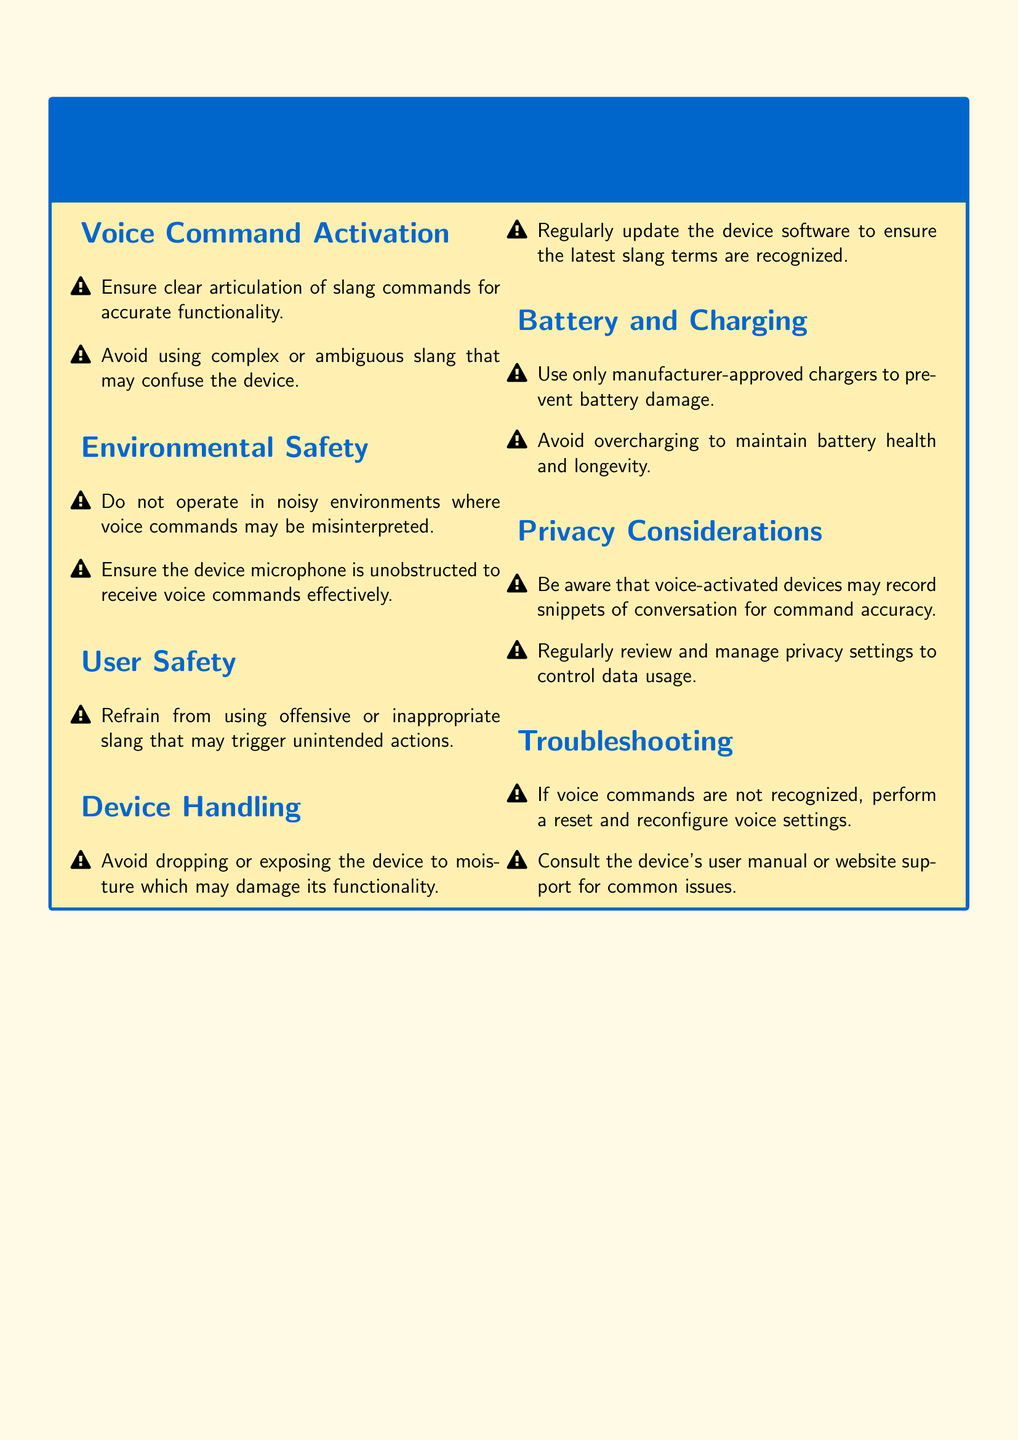What should you avoid using in voice commands? The document states to avoid using complex or ambiguous slang that may confuse the device.
Answer: complex or ambiguous slang What type of environments should the device not be operated in? The document highlights that it should not be operated in noisy environments where voice commands may be misinterpreted.
Answer: noisy environments What is a major consideration when handling the device? The document mentions to avoid dropping or exposing the device to moisture which may damage its functionality.
Answer: moisture How should the device be charged? The document specifies to use only manufacturer-approved chargers to prevent battery damage.
Answer: manufacturer-approved chargers What action is suggested if voice commands are not recognized? The document recommends performing a reset and reconfiguring voice settings.
Answer: reset and reconfigure What overarching safety topic does the first section address? The first section is concerned with the clarity and articulation of voice commands.
Answer: Voice Command Activation How often should the device software be updated? The document advises to regularly update the device software to ensure the latest slang terms are recognized.
Answer: regularly What can voice-activated devices record? The document points out that they may record snippets of conversation for command accuracy.
Answer: snippets of conversation What should be regularly reviewed in terms of privacy? The document states that privacy settings should be regularly reviewed and managed to control data usage.
Answer: privacy settings 